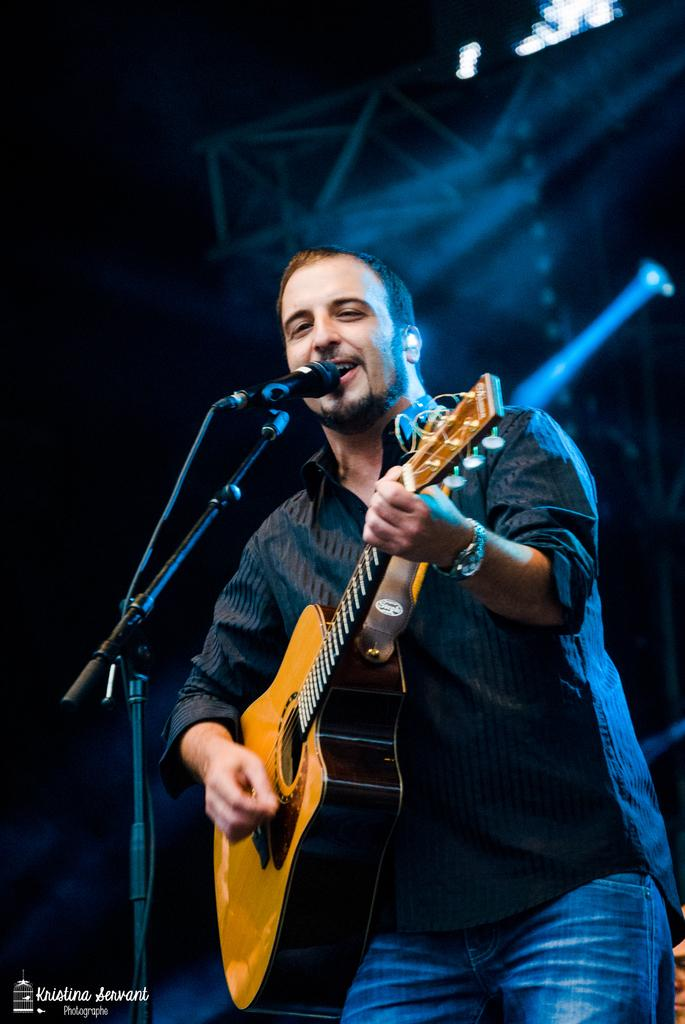What is the man in the image doing? The man is holding a guitar and singing into a microphone. What is the man wearing in the image? The man is wearing a black shirt with lines. What can be seen in the background of the image? There is a stand and lights in the background of the image. How many spiders are crawling on the desk in the image? There is no desk present in the image, and therefore no spiders can be observed. 